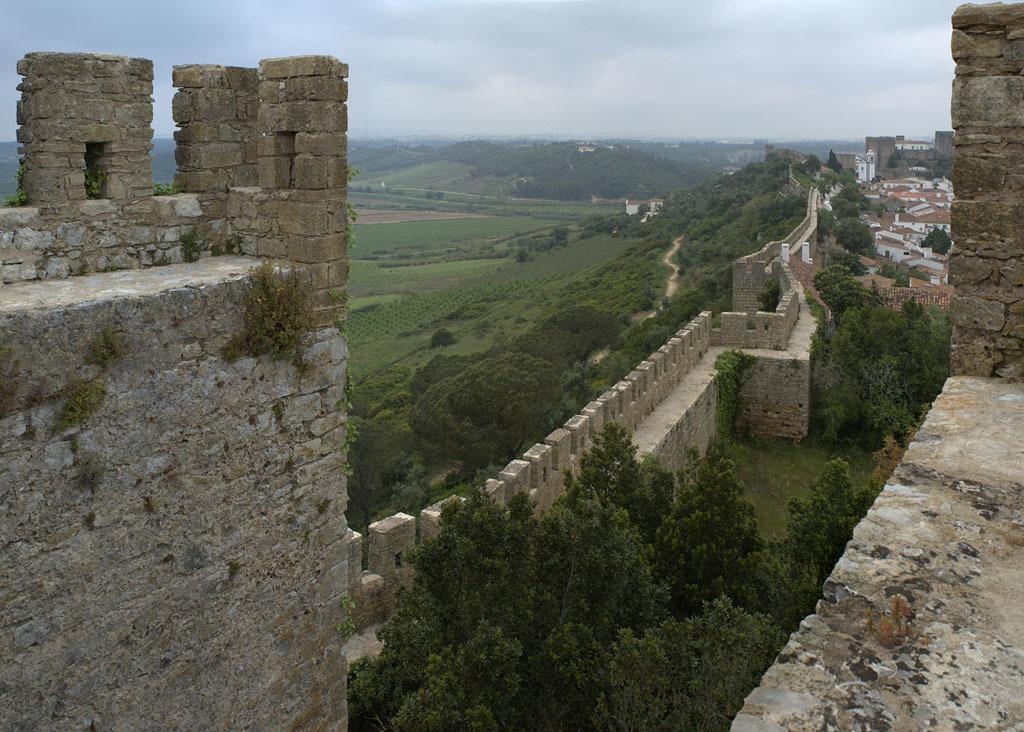How would you summarize this image in a sentence or two? In this picture we can see trees, walls and some objects and in the background we can see the sky. 